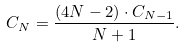<formula> <loc_0><loc_0><loc_500><loc_500>C _ { N } = \frac { ( 4 N - 2 ) \cdot C _ { N - 1 } } { N + 1 } .</formula> 